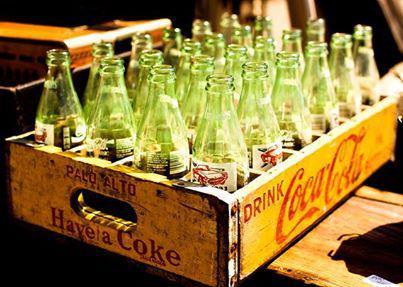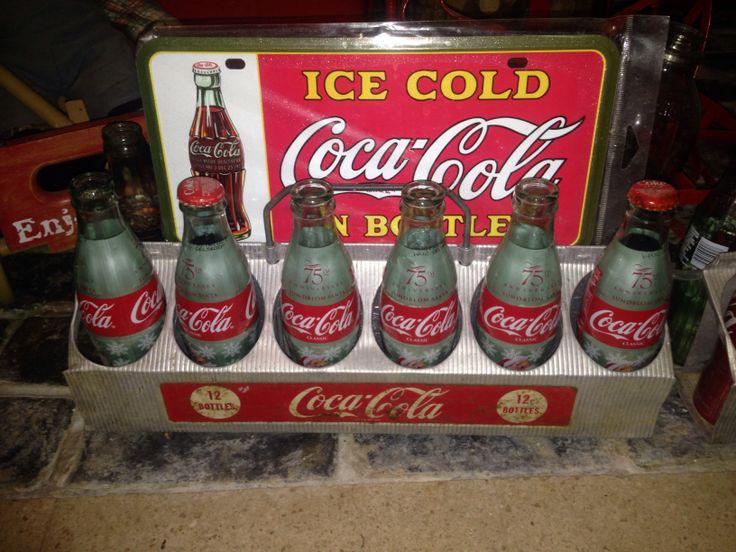The first image is the image on the left, the second image is the image on the right. For the images shown, is this caption "The left image features filled cola bottles in a red wooden crate with low sides." true? Answer yes or no. No. 